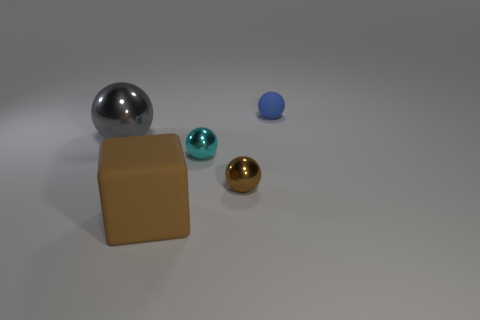Do the large thing that is in front of the cyan metallic thing and the small object behind the large gray metallic sphere have the same material?
Ensure brevity in your answer.  Yes. What is the small thing behind the cyan metal object made of?
Provide a succinct answer. Rubber. How many metal objects are large brown cubes or tiny brown cylinders?
Ensure brevity in your answer.  0. What is the color of the large thing that is in front of the small shiny object in front of the tiny cyan object?
Your answer should be compact. Brown. Are the gray thing and the tiny thing that is in front of the tiny cyan thing made of the same material?
Keep it short and to the point. Yes. There is a matte object in front of the ball behind the large sphere behind the large matte block; what is its color?
Your answer should be compact. Brown. Are there any other things that are the same shape as the large brown rubber object?
Your response must be concise. No. Is the number of large balls greater than the number of purple rubber balls?
Ensure brevity in your answer.  Yes. How many things are on the right side of the brown matte thing and in front of the cyan metallic object?
Keep it short and to the point. 1. There is a brown thing to the right of the big brown matte cube; how many large gray objects are to the right of it?
Offer a very short reply. 0. 